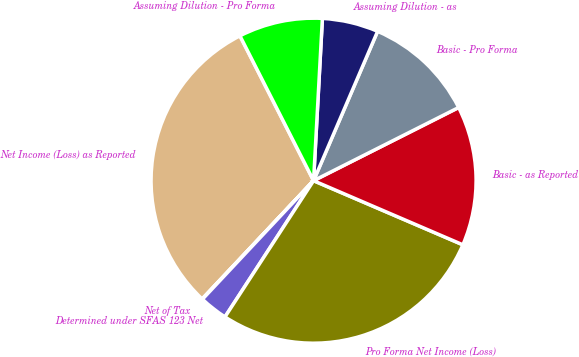Convert chart. <chart><loc_0><loc_0><loc_500><loc_500><pie_chart><fcel>Net Income (Loss) as Reported<fcel>Net of Tax<fcel>Determined under SFAS 123 Net<fcel>Pro Forma Net Income (Loss)<fcel>Basic - as Reported<fcel>Basic - Pro Forma<fcel>Assuming Dilution - as<fcel>Assuming Dilution - Pro Forma<nl><fcel>30.49%<fcel>0.04%<fcel>2.81%<fcel>27.72%<fcel>13.89%<fcel>11.12%<fcel>5.58%<fcel>8.35%<nl></chart> 